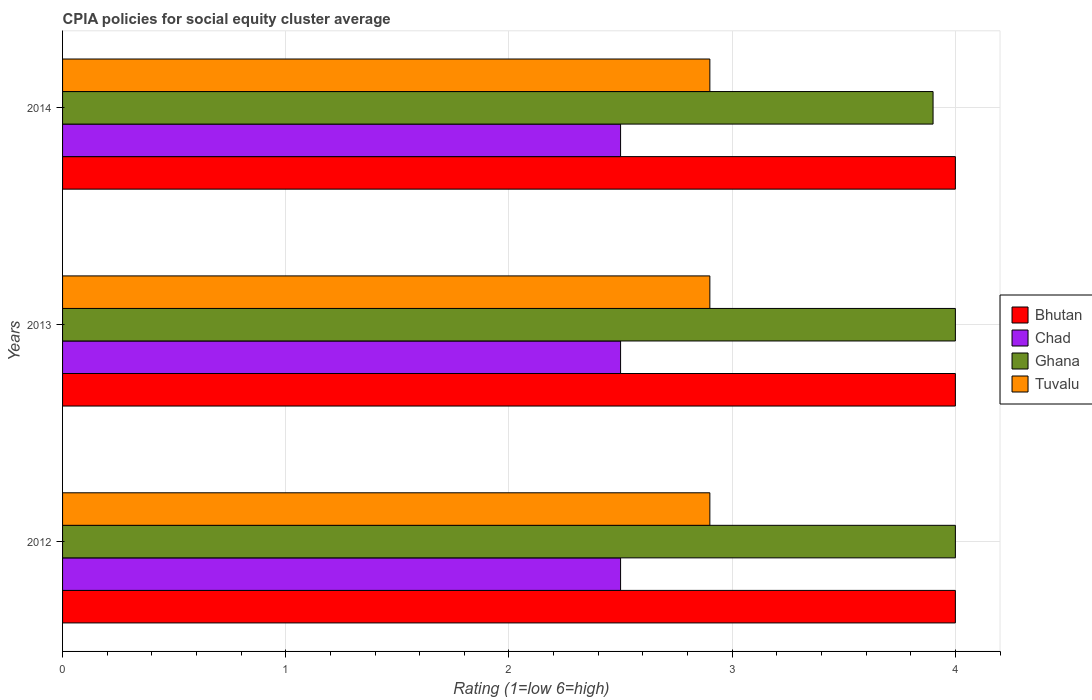Are the number of bars on each tick of the Y-axis equal?
Make the answer very short. Yes. How many bars are there on the 3rd tick from the top?
Offer a very short reply. 4. How many bars are there on the 2nd tick from the bottom?
Ensure brevity in your answer.  4. What is the label of the 2nd group of bars from the top?
Your response must be concise. 2013. In how many cases, is the number of bars for a given year not equal to the number of legend labels?
Your answer should be compact. 0. Across all years, what is the maximum CPIA rating in Tuvalu?
Your response must be concise. 2.9. What is the difference between the CPIA rating in Ghana in 2012 and that in 2014?
Provide a short and direct response. 0.1. What is the average CPIA rating in Ghana per year?
Ensure brevity in your answer.  3.97. In the year 2013, what is the difference between the CPIA rating in Chad and CPIA rating in Tuvalu?
Offer a terse response. -0.4. Is the CPIA rating in Ghana in 2012 less than that in 2013?
Offer a very short reply. No. What is the difference between the highest and the lowest CPIA rating in Tuvalu?
Provide a succinct answer. 0. In how many years, is the CPIA rating in Bhutan greater than the average CPIA rating in Bhutan taken over all years?
Your response must be concise. 0. Is the sum of the CPIA rating in Tuvalu in 2012 and 2013 greater than the maximum CPIA rating in Ghana across all years?
Your response must be concise. Yes. Is it the case that in every year, the sum of the CPIA rating in Bhutan and CPIA rating in Ghana is greater than the sum of CPIA rating in Tuvalu and CPIA rating in Chad?
Provide a short and direct response. Yes. What does the 3rd bar from the top in 2013 represents?
Provide a succinct answer. Chad. What does the 1st bar from the bottom in 2014 represents?
Your answer should be very brief. Bhutan. How many bars are there?
Keep it short and to the point. 12. Are all the bars in the graph horizontal?
Give a very brief answer. Yes. Are the values on the major ticks of X-axis written in scientific E-notation?
Your response must be concise. No. Does the graph contain any zero values?
Provide a short and direct response. No. Where does the legend appear in the graph?
Provide a short and direct response. Center right. How many legend labels are there?
Offer a very short reply. 4. How are the legend labels stacked?
Ensure brevity in your answer.  Vertical. What is the title of the graph?
Ensure brevity in your answer.  CPIA policies for social equity cluster average. What is the Rating (1=low 6=high) in Bhutan in 2012?
Your answer should be very brief. 4. What is the Rating (1=low 6=high) of Bhutan in 2013?
Offer a very short reply. 4. What is the Rating (1=low 6=high) of Ghana in 2013?
Your answer should be compact. 4. What is the Rating (1=low 6=high) in Chad in 2014?
Provide a short and direct response. 2.5. What is the Rating (1=low 6=high) in Ghana in 2014?
Provide a short and direct response. 3.9. Across all years, what is the maximum Rating (1=low 6=high) in Bhutan?
Offer a very short reply. 4. Across all years, what is the maximum Rating (1=low 6=high) of Ghana?
Provide a short and direct response. 4. Across all years, what is the minimum Rating (1=low 6=high) of Bhutan?
Provide a short and direct response. 4. Across all years, what is the minimum Rating (1=low 6=high) in Chad?
Ensure brevity in your answer.  2.5. What is the total Rating (1=low 6=high) of Bhutan in the graph?
Ensure brevity in your answer.  12. What is the total Rating (1=low 6=high) of Chad in the graph?
Give a very brief answer. 7.5. What is the total Rating (1=low 6=high) of Tuvalu in the graph?
Ensure brevity in your answer.  8.7. What is the difference between the Rating (1=low 6=high) of Chad in 2012 and that in 2013?
Offer a terse response. 0. What is the difference between the Rating (1=low 6=high) in Tuvalu in 2012 and that in 2014?
Offer a terse response. 0. What is the difference between the Rating (1=low 6=high) of Bhutan in 2013 and that in 2014?
Make the answer very short. 0. What is the difference between the Rating (1=low 6=high) in Chad in 2013 and that in 2014?
Keep it short and to the point. 0. What is the difference between the Rating (1=low 6=high) of Ghana in 2013 and that in 2014?
Give a very brief answer. 0.1. What is the difference between the Rating (1=low 6=high) of Tuvalu in 2013 and that in 2014?
Your answer should be very brief. 0. What is the difference between the Rating (1=low 6=high) in Bhutan in 2012 and the Rating (1=low 6=high) in Chad in 2013?
Your response must be concise. 1.5. What is the difference between the Rating (1=low 6=high) of Bhutan in 2012 and the Rating (1=low 6=high) of Ghana in 2013?
Provide a succinct answer. 0. What is the difference between the Rating (1=low 6=high) in Bhutan in 2012 and the Rating (1=low 6=high) in Tuvalu in 2013?
Keep it short and to the point. 1.1. What is the difference between the Rating (1=low 6=high) in Chad in 2012 and the Rating (1=low 6=high) in Ghana in 2013?
Provide a succinct answer. -1.5. What is the difference between the Rating (1=low 6=high) of Chad in 2012 and the Rating (1=low 6=high) of Tuvalu in 2013?
Offer a terse response. -0.4. What is the difference between the Rating (1=low 6=high) of Ghana in 2012 and the Rating (1=low 6=high) of Tuvalu in 2013?
Your answer should be very brief. 1.1. What is the difference between the Rating (1=low 6=high) in Chad in 2012 and the Rating (1=low 6=high) in Ghana in 2014?
Your answer should be very brief. -1.4. What is the difference between the Rating (1=low 6=high) in Bhutan in 2013 and the Rating (1=low 6=high) in Ghana in 2014?
Ensure brevity in your answer.  0.1. What is the difference between the Rating (1=low 6=high) of Chad in 2013 and the Rating (1=low 6=high) of Tuvalu in 2014?
Ensure brevity in your answer.  -0.4. What is the average Rating (1=low 6=high) in Chad per year?
Offer a terse response. 2.5. What is the average Rating (1=low 6=high) in Ghana per year?
Ensure brevity in your answer.  3.97. In the year 2012, what is the difference between the Rating (1=low 6=high) in Bhutan and Rating (1=low 6=high) in Chad?
Keep it short and to the point. 1.5. In the year 2012, what is the difference between the Rating (1=low 6=high) of Bhutan and Rating (1=low 6=high) of Ghana?
Offer a terse response. 0. In the year 2012, what is the difference between the Rating (1=low 6=high) in Chad and Rating (1=low 6=high) in Ghana?
Your answer should be very brief. -1.5. In the year 2013, what is the difference between the Rating (1=low 6=high) of Bhutan and Rating (1=low 6=high) of Tuvalu?
Keep it short and to the point. 1.1. In the year 2013, what is the difference between the Rating (1=low 6=high) of Chad and Rating (1=low 6=high) of Ghana?
Make the answer very short. -1.5. In the year 2013, what is the difference between the Rating (1=low 6=high) in Chad and Rating (1=low 6=high) in Tuvalu?
Your response must be concise. -0.4. In the year 2014, what is the difference between the Rating (1=low 6=high) in Bhutan and Rating (1=low 6=high) in Chad?
Ensure brevity in your answer.  1.5. In the year 2014, what is the difference between the Rating (1=low 6=high) of Bhutan and Rating (1=low 6=high) of Ghana?
Offer a very short reply. 0.1. In the year 2014, what is the difference between the Rating (1=low 6=high) in Chad and Rating (1=low 6=high) in Ghana?
Ensure brevity in your answer.  -1.4. In the year 2014, what is the difference between the Rating (1=low 6=high) in Ghana and Rating (1=low 6=high) in Tuvalu?
Provide a short and direct response. 1. What is the ratio of the Rating (1=low 6=high) of Bhutan in 2012 to that in 2013?
Provide a succinct answer. 1. What is the ratio of the Rating (1=low 6=high) of Chad in 2012 to that in 2013?
Give a very brief answer. 1. What is the ratio of the Rating (1=low 6=high) of Ghana in 2012 to that in 2013?
Provide a short and direct response. 1. What is the ratio of the Rating (1=low 6=high) in Bhutan in 2012 to that in 2014?
Offer a very short reply. 1. What is the ratio of the Rating (1=low 6=high) of Chad in 2012 to that in 2014?
Offer a terse response. 1. What is the ratio of the Rating (1=low 6=high) of Ghana in 2012 to that in 2014?
Ensure brevity in your answer.  1.03. What is the ratio of the Rating (1=low 6=high) in Tuvalu in 2012 to that in 2014?
Ensure brevity in your answer.  1. What is the ratio of the Rating (1=low 6=high) of Bhutan in 2013 to that in 2014?
Ensure brevity in your answer.  1. What is the ratio of the Rating (1=low 6=high) in Chad in 2013 to that in 2014?
Keep it short and to the point. 1. What is the ratio of the Rating (1=low 6=high) in Ghana in 2013 to that in 2014?
Provide a short and direct response. 1.03. What is the ratio of the Rating (1=low 6=high) in Tuvalu in 2013 to that in 2014?
Give a very brief answer. 1. What is the difference between the highest and the second highest Rating (1=low 6=high) of Chad?
Offer a very short reply. 0. What is the difference between the highest and the second highest Rating (1=low 6=high) of Tuvalu?
Make the answer very short. 0. What is the difference between the highest and the lowest Rating (1=low 6=high) of Bhutan?
Your answer should be compact. 0. What is the difference between the highest and the lowest Rating (1=low 6=high) in Chad?
Your answer should be very brief. 0. What is the difference between the highest and the lowest Rating (1=low 6=high) of Ghana?
Ensure brevity in your answer.  0.1. 